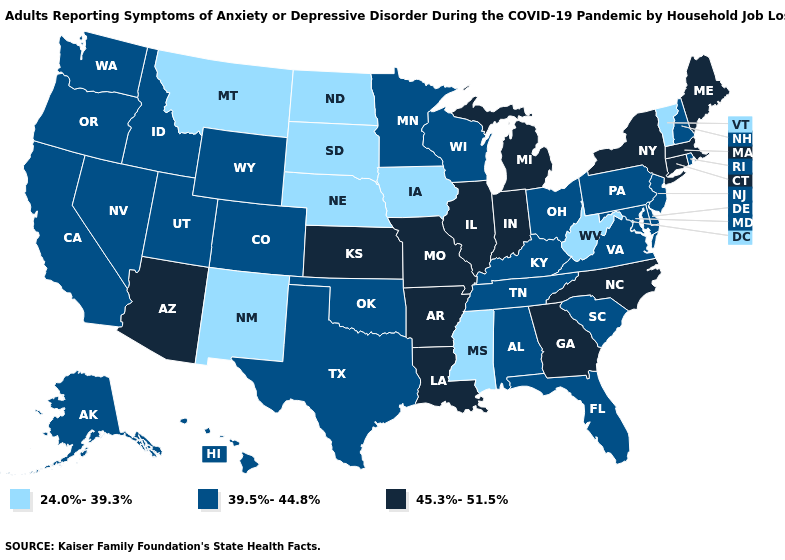Name the states that have a value in the range 24.0%-39.3%?
Answer briefly. Iowa, Mississippi, Montana, Nebraska, New Mexico, North Dakota, South Dakota, Vermont, West Virginia. What is the value of Texas?
Concise answer only. 39.5%-44.8%. Name the states that have a value in the range 45.3%-51.5%?
Answer briefly. Arizona, Arkansas, Connecticut, Georgia, Illinois, Indiana, Kansas, Louisiana, Maine, Massachusetts, Michigan, Missouri, New York, North Carolina. Does Missouri have the highest value in the MidWest?
Short answer required. Yes. What is the value of Vermont?
Keep it brief. 24.0%-39.3%. Which states hav the highest value in the South?
Short answer required. Arkansas, Georgia, Louisiana, North Carolina. What is the value of Iowa?
Be succinct. 24.0%-39.3%. Name the states that have a value in the range 45.3%-51.5%?
Answer briefly. Arizona, Arkansas, Connecticut, Georgia, Illinois, Indiana, Kansas, Louisiana, Maine, Massachusetts, Michigan, Missouri, New York, North Carolina. Is the legend a continuous bar?
Give a very brief answer. No. What is the lowest value in the USA?
Write a very short answer. 24.0%-39.3%. What is the lowest value in the USA?
Write a very short answer. 24.0%-39.3%. What is the lowest value in states that border Nebraska?
Be succinct. 24.0%-39.3%. What is the highest value in states that border New York?
Quick response, please. 45.3%-51.5%. What is the value of Nevada?
Be succinct. 39.5%-44.8%. What is the lowest value in the USA?
Concise answer only. 24.0%-39.3%. 